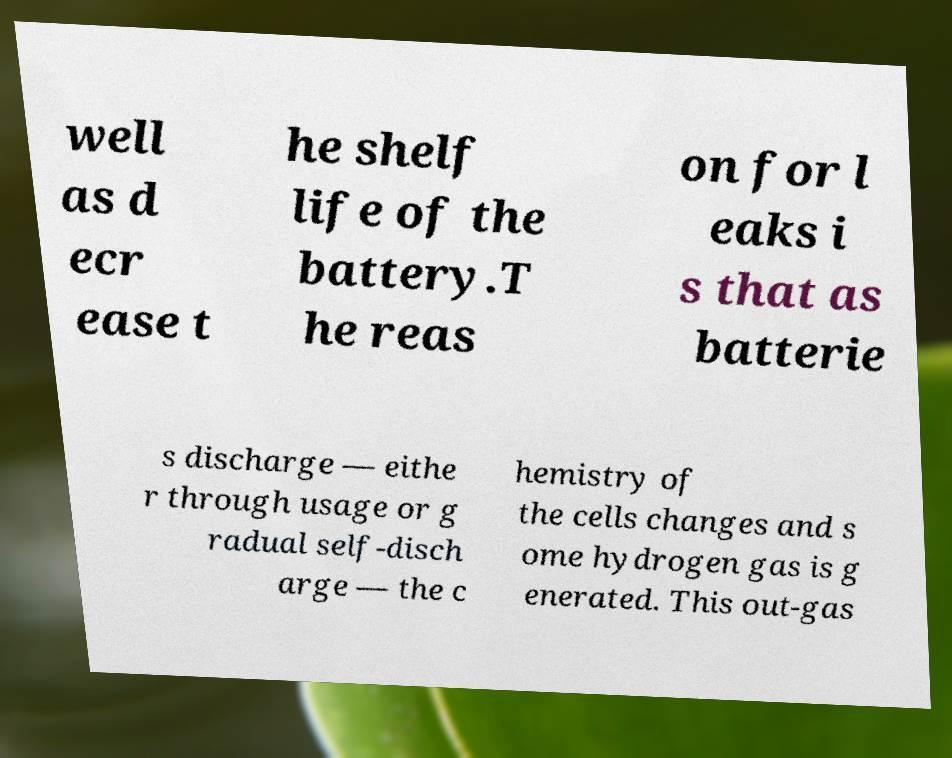Can you accurately transcribe the text from the provided image for me? well as d ecr ease t he shelf life of the battery.T he reas on for l eaks i s that as batterie s discharge — eithe r through usage or g radual self-disch arge — the c hemistry of the cells changes and s ome hydrogen gas is g enerated. This out-gas 